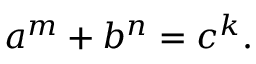<formula> <loc_0><loc_0><loc_500><loc_500>a ^ { m } + b ^ { n } = c ^ { k } .</formula> 